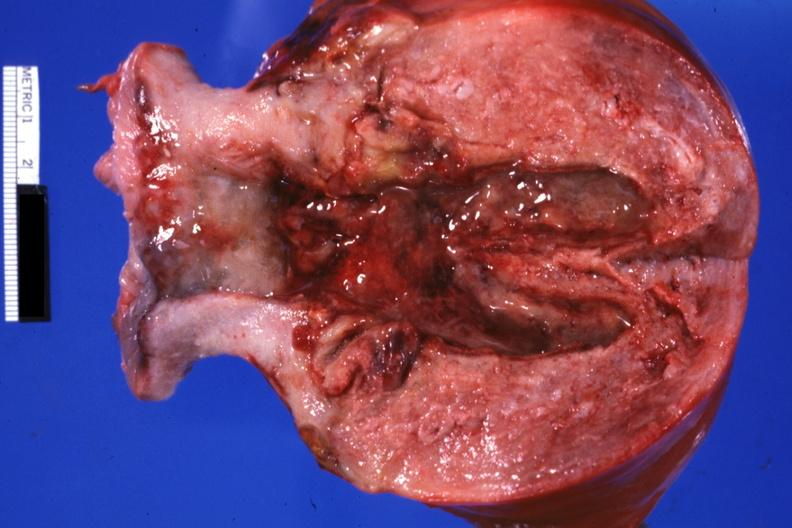what is present?
Answer the question using a single word or phrase. Endometritis postpartum 